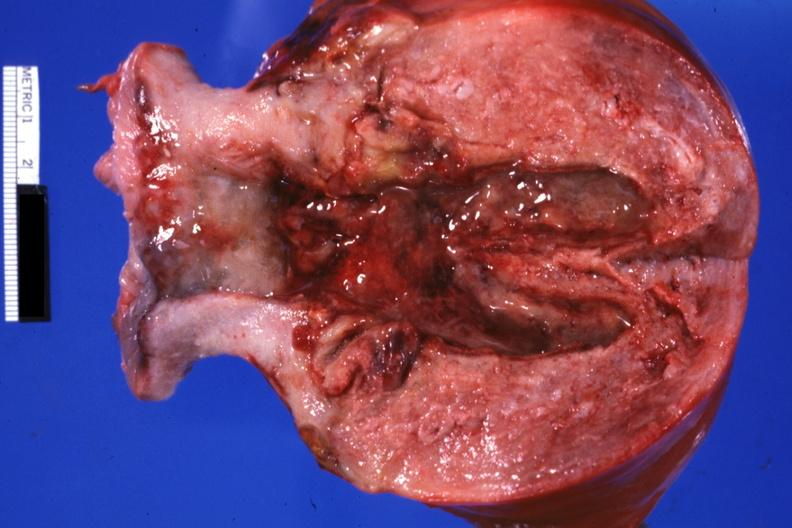what is present?
Answer the question using a single word or phrase. Endometritis postpartum 